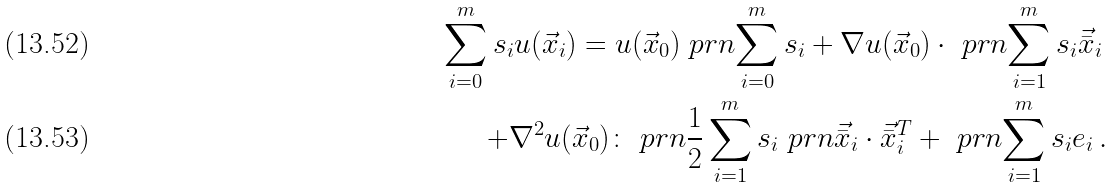<formula> <loc_0><loc_0><loc_500><loc_500>\sum _ { i = 0 } ^ { m } s _ { i } u ( \vec { x } _ { i } ) = u ( \vec { x } _ { 0 } ) \ p r n { \sum _ { i = 0 } ^ { m } s _ { i } } + \nabla u ( \vec { x } _ { 0 } ) \cdot \ p r n { \sum _ { i = 1 } ^ { m } s _ { i } \vec { \bar { x } } _ { i } } \, \\ + \nabla ^ { 2 } u ( \vec { x } _ { 0 } ) \colon \ p r n { \frac { 1 } { 2 } \sum _ { i = 1 } ^ { m } s _ { i } \ p r n { \vec { \bar { x } } _ { i } \cdot \vec { \bar { x } } _ { i } ^ { T } } } + \ p r n { \sum _ { i = 1 } ^ { m } s _ { i } e _ { i } } \, .</formula> 